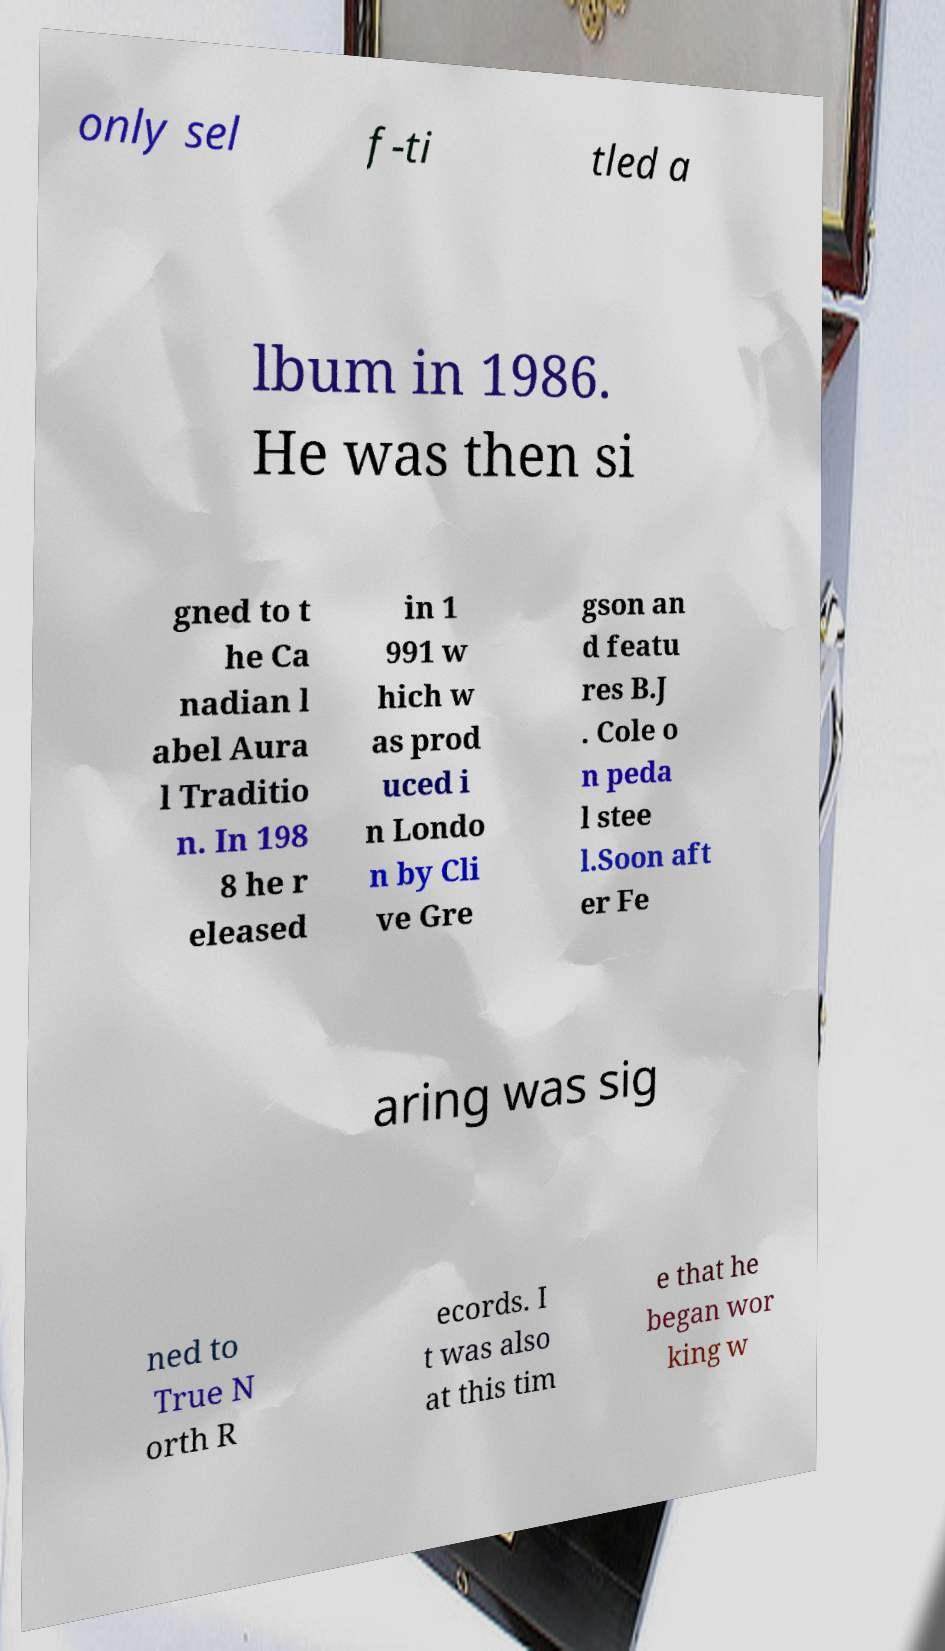I need the written content from this picture converted into text. Can you do that? only sel f-ti tled a lbum in 1986. He was then si gned to t he Ca nadian l abel Aura l Traditio n. In 198 8 he r eleased in 1 991 w hich w as prod uced i n Londo n by Cli ve Gre gson an d featu res B.J . Cole o n peda l stee l.Soon aft er Fe aring was sig ned to True N orth R ecords. I t was also at this tim e that he began wor king w 